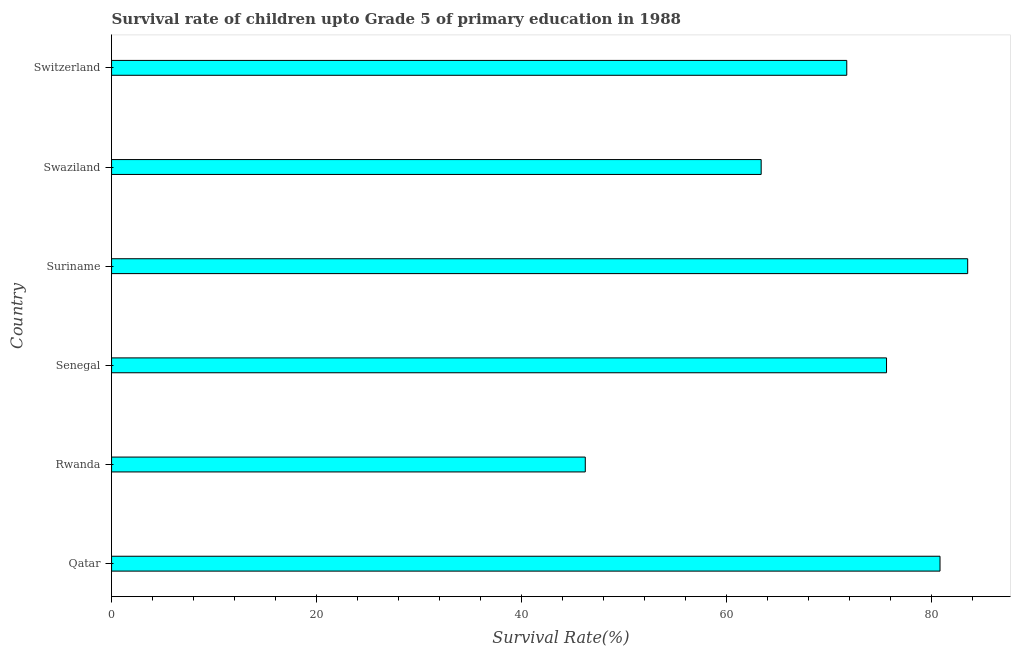Does the graph contain any zero values?
Your response must be concise. No. What is the title of the graph?
Provide a short and direct response. Survival rate of children upto Grade 5 of primary education in 1988 . What is the label or title of the X-axis?
Give a very brief answer. Survival Rate(%). What is the survival rate in Suriname?
Make the answer very short. 83.54. Across all countries, what is the maximum survival rate?
Provide a succinct answer. 83.54. Across all countries, what is the minimum survival rate?
Your answer should be very brief. 46.22. In which country was the survival rate maximum?
Provide a succinct answer. Suriname. In which country was the survival rate minimum?
Your answer should be very brief. Rwanda. What is the sum of the survival rate?
Provide a succinct answer. 421.34. What is the difference between the survival rate in Qatar and Swaziland?
Your answer should be compact. 17.45. What is the average survival rate per country?
Provide a succinct answer. 70.22. What is the median survival rate?
Your answer should be compact. 73.68. What is the ratio of the survival rate in Rwanda to that in Switzerland?
Provide a succinct answer. 0.64. Is the difference between the survival rate in Swaziland and Switzerland greater than the difference between any two countries?
Your response must be concise. No. Is the sum of the survival rate in Senegal and Swaziland greater than the maximum survival rate across all countries?
Ensure brevity in your answer.  Yes. What is the difference between the highest and the lowest survival rate?
Keep it short and to the point. 37.31. How many countries are there in the graph?
Give a very brief answer. 6. Are the values on the major ticks of X-axis written in scientific E-notation?
Your answer should be very brief. No. What is the Survival Rate(%) of Qatar?
Your answer should be compact. 80.84. What is the Survival Rate(%) in Rwanda?
Ensure brevity in your answer.  46.22. What is the Survival Rate(%) in Senegal?
Ensure brevity in your answer.  75.62. What is the Survival Rate(%) of Suriname?
Offer a very short reply. 83.54. What is the Survival Rate(%) of Swaziland?
Give a very brief answer. 63.39. What is the Survival Rate(%) of Switzerland?
Provide a short and direct response. 71.74. What is the difference between the Survival Rate(%) in Qatar and Rwanda?
Offer a terse response. 34.61. What is the difference between the Survival Rate(%) in Qatar and Senegal?
Give a very brief answer. 5.22. What is the difference between the Survival Rate(%) in Qatar and Suriname?
Your answer should be compact. -2.7. What is the difference between the Survival Rate(%) in Qatar and Swaziland?
Keep it short and to the point. 17.45. What is the difference between the Survival Rate(%) in Qatar and Switzerland?
Provide a succinct answer. 9.1. What is the difference between the Survival Rate(%) in Rwanda and Senegal?
Your response must be concise. -29.39. What is the difference between the Survival Rate(%) in Rwanda and Suriname?
Give a very brief answer. -37.31. What is the difference between the Survival Rate(%) in Rwanda and Swaziland?
Your answer should be very brief. -17.16. What is the difference between the Survival Rate(%) in Rwanda and Switzerland?
Your answer should be compact. -25.51. What is the difference between the Survival Rate(%) in Senegal and Suriname?
Provide a short and direct response. -7.92. What is the difference between the Survival Rate(%) in Senegal and Swaziland?
Keep it short and to the point. 12.23. What is the difference between the Survival Rate(%) in Senegal and Switzerland?
Ensure brevity in your answer.  3.88. What is the difference between the Survival Rate(%) in Suriname and Swaziland?
Provide a succinct answer. 20.15. What is the difference between the Survival Rate(%) in Suriname and Switzerland?
Your answer should be very brief. 11.8. What is the difference between the Survival Rate(%) in Swaziland and Switzerland?
Offer a very short reply. -8.35. What is the ratio of the Survival Rate(%) in Qatar to that in Rwanda?
Offer a terse response. 1.75. What is the ratio of the Survival Rate(%) in Qatar to that in Senegal?
Your answer should be compact. 1.07. What is the ratio of the Survival Rate(%) in Qatar to that in Suriname?
Ensure brevity in your answer.  0.97. What is the ratio of the Survival Rate(%) in Qatar to that in Swaziland?
Your response must be concise. 1.27. What is the ratio of the Survival Rate(%) in Qatar to that in Switzerland?
Ensure brevity in your answer.  1.13. What is the ratio of the Survival Rate(%) in Rwanda to that in Senegal?
Your answer should be compact. 0.61. What is the ratio of the Survival Rate(%) in Rwanda to that in Suriname?
Make the answer very short. 0.55. What is the ratio of the Survival Rate(%) in Rwanda to that in Swaziland?
Your answer should be compact. 0.73. What is the ratio of the Survival Rate(%) in Rwanda to that in Switzerland?
Offer a very short reply. 0.64. What is the ratio of the Survival Rate(%) in Senegal to that in Suriname?
Ensure brevity in your answer.  0.91. What is the ratio of the Survival Rate(%) in Senegal to that in Swaziland?
Ensure brevity in your answer.  1.19. What is the ratio of the Survival Rate(%) in Senegal to that in Switzerland?
Offer a very short reply. 1.05. What is the ratio of the Survival Rate(%) in Suriname to that in Swaziland?
Keep it short and to the point. 1.32. What is the ratio of the Survival Rate(%) in Suriname to that in Switzerland?
Provide a succinct answer. 1.16. What is the ratio of the Survival Rate(%) in Swaziland to that in Switzerland?
Provide a succinct answer. 0.88. 